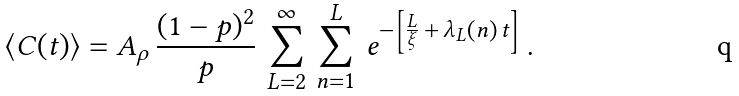Convert formula to latex. <formula><loc_0><loc_0><loc_500><loc_500>\langle C ( t ) \rangle = A _ { \rho } \, \frac { ( 1 - p ) ^ { 2 } } { p } \, \sum _ { L = 2 } ^ { \infty } \, \sum _ { n = 1 } ^ { L } \, e ^ { - \left [ \frac { L } { \xi } \, + \, \lambda _ { L } ( n ) \, t \right ] } \, .</formula> 